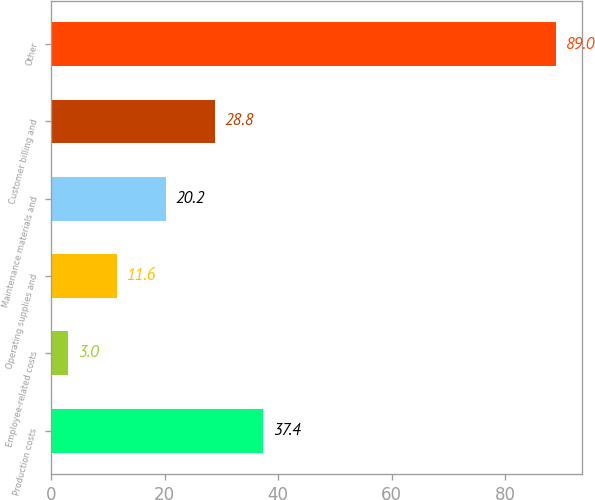Convert chart to OTSL. <chart><loc_0><loc_0><loc_500><loc_500><bar_chart><fcel>Production costs<fcel>Employee-related costs<fcel>Operating supplies and<fcel>Maintenance materials and<fcel>Customer billing and<fcel>Other<nl><fcel>37.4<fcel>3<fcel>11.6<fcel>20.2<fcel>28.8<fcel>89<nl></chart> 